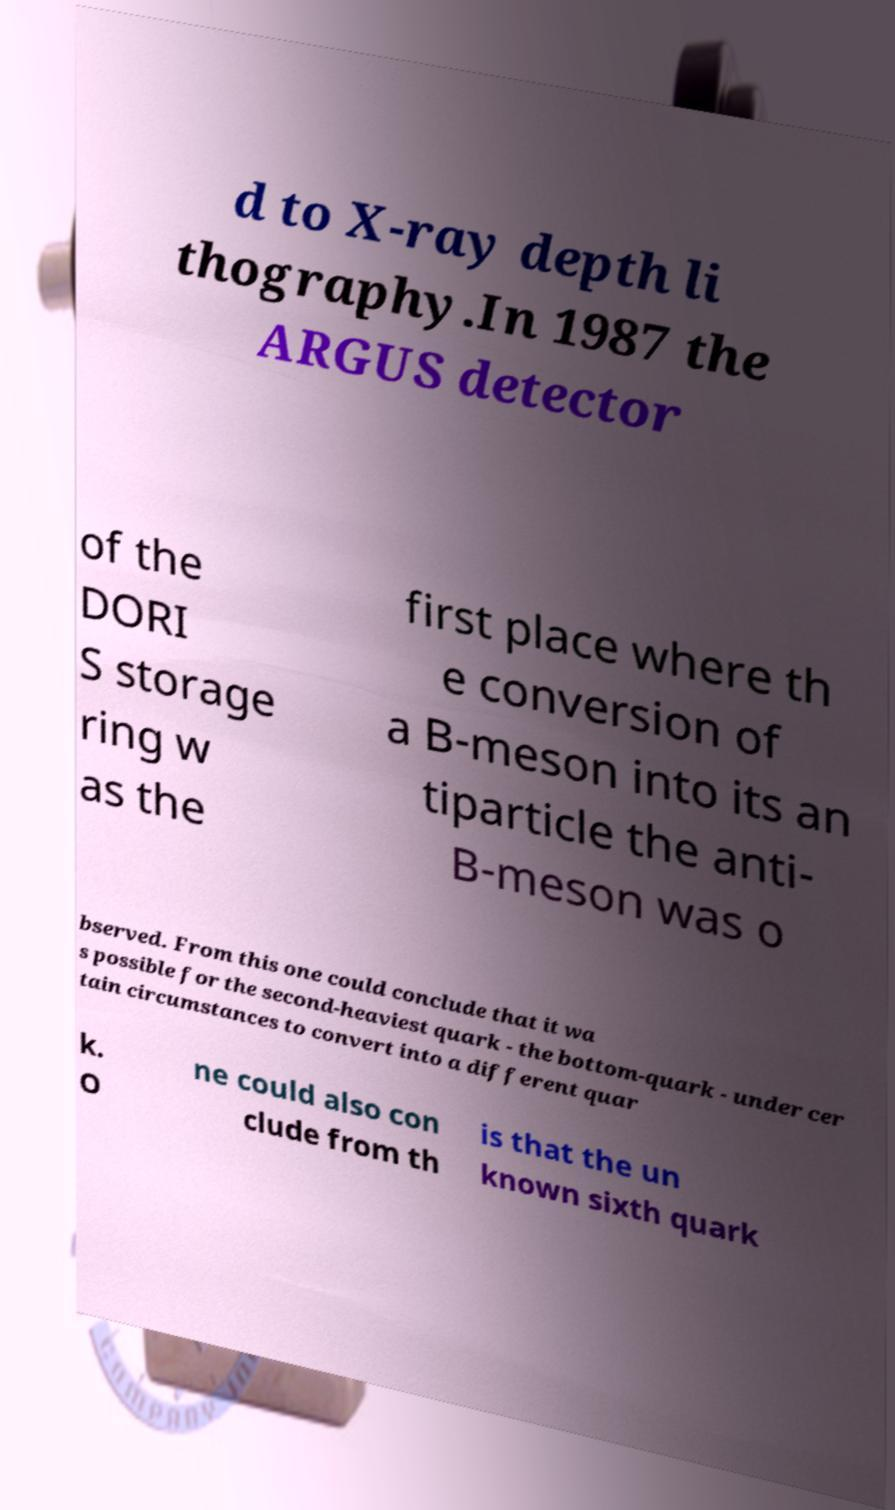Please read and relay the text visible in this image. What does it say? d to X-ray depth li thography.In 1987 the ARGUS detector of the DORI S storage ring w as the first place where th e conversion of a B-meson into its an tiparticle the anti- B-meson was o bserved. From this one could conclude that it wa s possible for the second-heaviest quark - the bottom-quark - under cer tain circumstances to convert into a different quar k. O ne could also con clude from th is that the un known sixth quark 